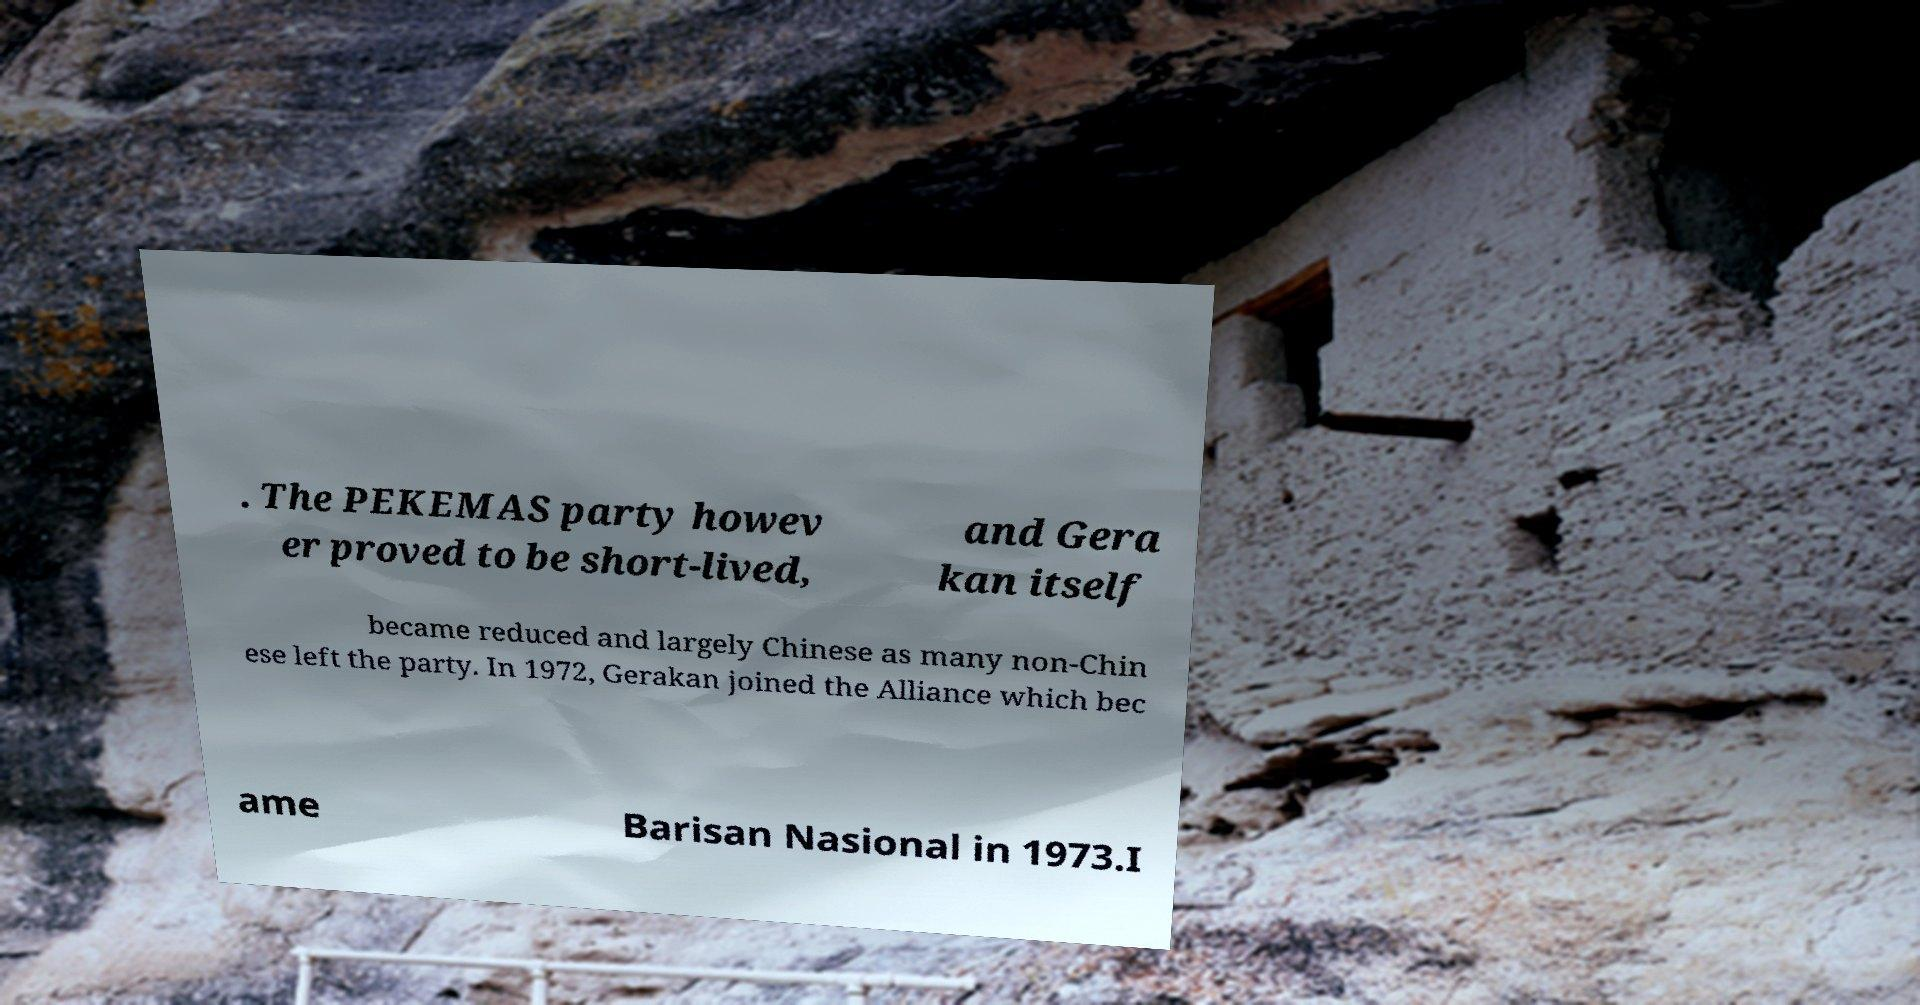Could you assist in decoding the text presented in this image and type it out clearly? . The PEKEMAS party howev er proved to be short-lived, and Gera kan itself became reduced and largely Chinese as many non-Chin ese left the party. In 1972, Gerakan joined the Alliance which bec ame Barisan Nasional in 1973.I 